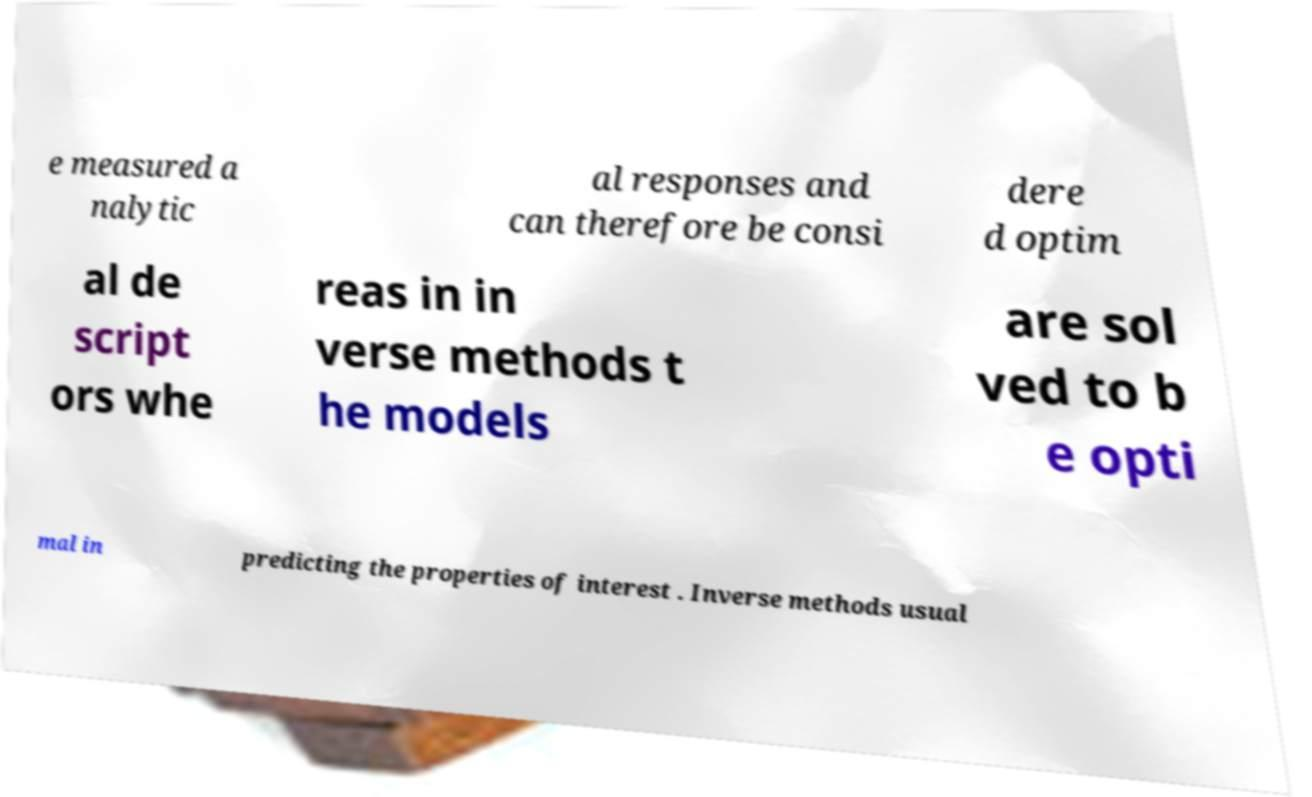Could you assist in decoding the text presented in this image and type it out clearly? e measured a nalytic al responses and can therefore be consi dere d optim al de script ors whe reas in in verse methods t he models are sol ved to b e opti mal in predicting the properties of interest . Inverse methods usual 